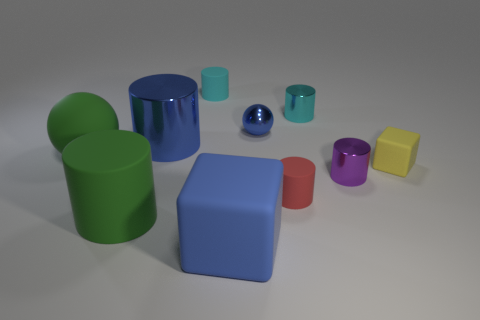Subtract all blue spheres. How many cyan cylinders are left? 2 Subtract all tiny cylinders. How many cylinders are left? 2 Subtract all green cylinders. How many cylinders are left? 5 Subtract all balls. How many objects are left? 8 Subtract 0 red balls. How many objects are left? 10 Subtract all yellow balls. Subtract all green cubes. How many balls are left? 2 Subtract all blue things. Subtract all small purple shiny spheres. How many objects are left? 7 Add 3 blue blocks. How many blue blocks are left? 4 Add 3 big rubber things. How many big rubber things exist? 6 